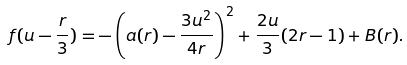<formula> <loc_0><loc_0><loc_500><loc_500>f ( u - \frac { r } { 3 } ) = - \left ( a ( r ) - \frac { 3 u ^ { 2 } } { 4 r } \right ) ^ { 2 } + \frac { 2 u } { 3 } ( 2 r - 1 ) + B ( r ) .</formula> 